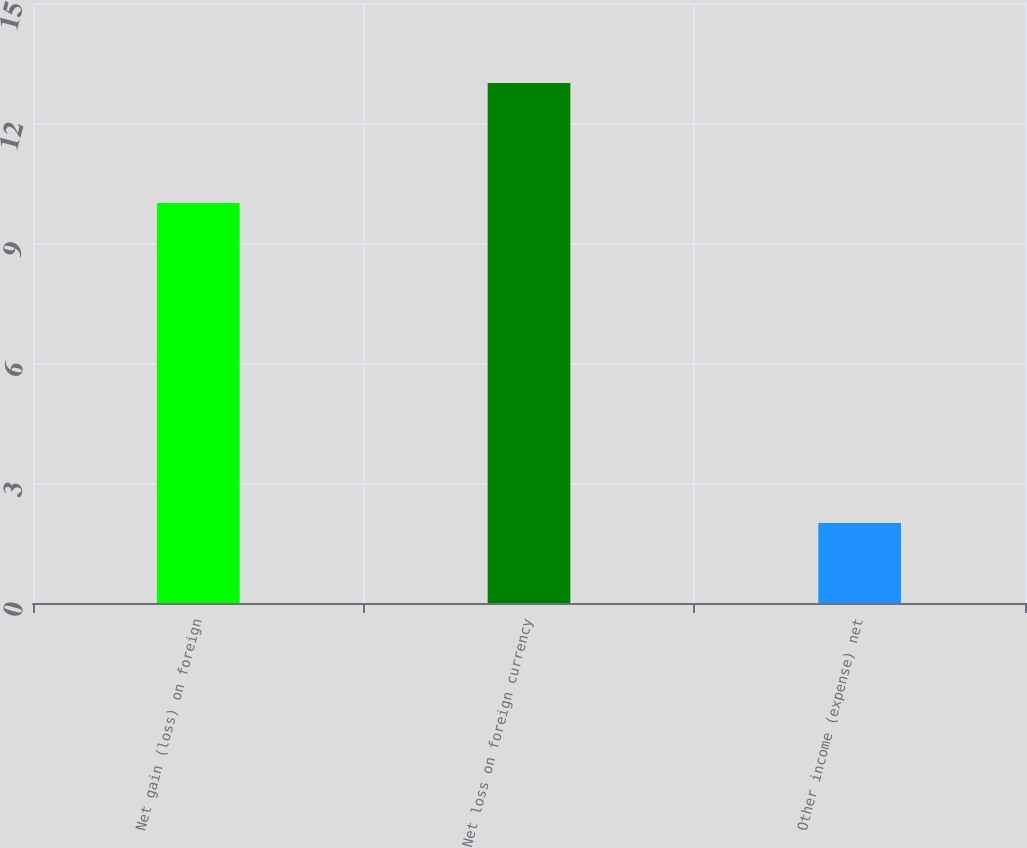Convert chart to OTSL. <chart><loc_0><loc_0><loc_500><loc_500><bar_chart><fcel>Net gain (loss) on foreign<fcel>Net loss on foreign currency<fcel>Other income (expense) net<nl><fcel>10<fcel>13<fcel>2<nl></chart> 